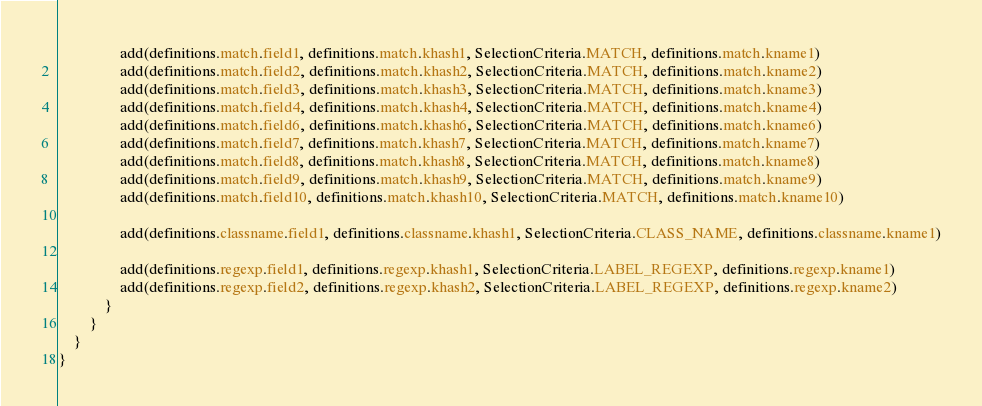Convert code to text. <code><loc_0><loc_0><loc_500><loc_500><_Kotlin_>
                add(definitions.match.field1, definitions.match.khash1, SelectionCriteria.MATCH, definitions.match.kname1)
                add(definitions.match.field2, definitions.match.khash2, SelectionCriteria.MATCH, definitions.match.kname2)
                add(definitions.match.field3, definitions.match.khash3, SelectionCriteria.MATCH, definitions.match.kname3)
                add(definitions.match.field4, definitions.match.khash4, SelectionCriteria.MATCH, definitions.match.kname4)
                add(definitions.match.field6, definitions.match.khash6, SelectionCriteria.MATCH, definitions.match.kname6)
                add(definitions.match.field7, definitions.match.khash7, SelectionCriteria.MATCH, definitions.match.kname7)
                add(definitions.match.field8, definitions.match.khash8, SelectionCriteria.MATCH, definitions.match.kname8)
                add(definitions.match.field9, definitions.match.khash9, SelectionCriteria.MATCH, definitions.match.kname9)
                add(definitions.match.field10, definitions.match.khash10, SelectionCriteria.MATCH, definitions.match.kname10)

                add(definitions.classname.field1, definitions.classname.khash1, SelectionCriteria.CLASS_NAME, definitions.classname.kname1)

                add(definitions.regexp.field1, definitions.regexp.khash1, SelectionCriteria.LABEL_REGEXP, definitions.regexp.kname1)
                add(definitions.regexp.field2, definitions.regexp.khash2, SelectionCriteria.LABEL_REGEXP, definitions.regexp.kname2)
            }
        }
    }
}</code> 